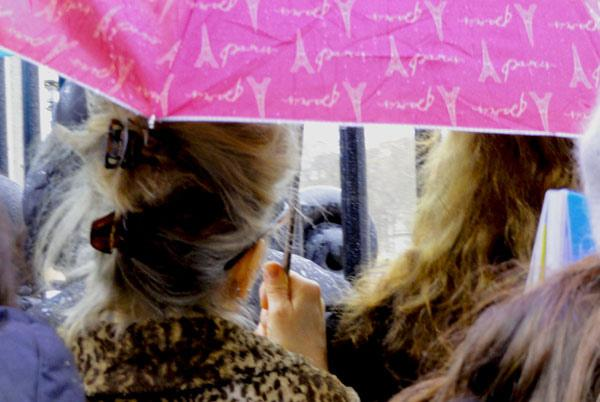What do the clips on the woman's head do for her? Please explain your reasoning. hold hair. The clips on the woman's head keep her hair in place. 